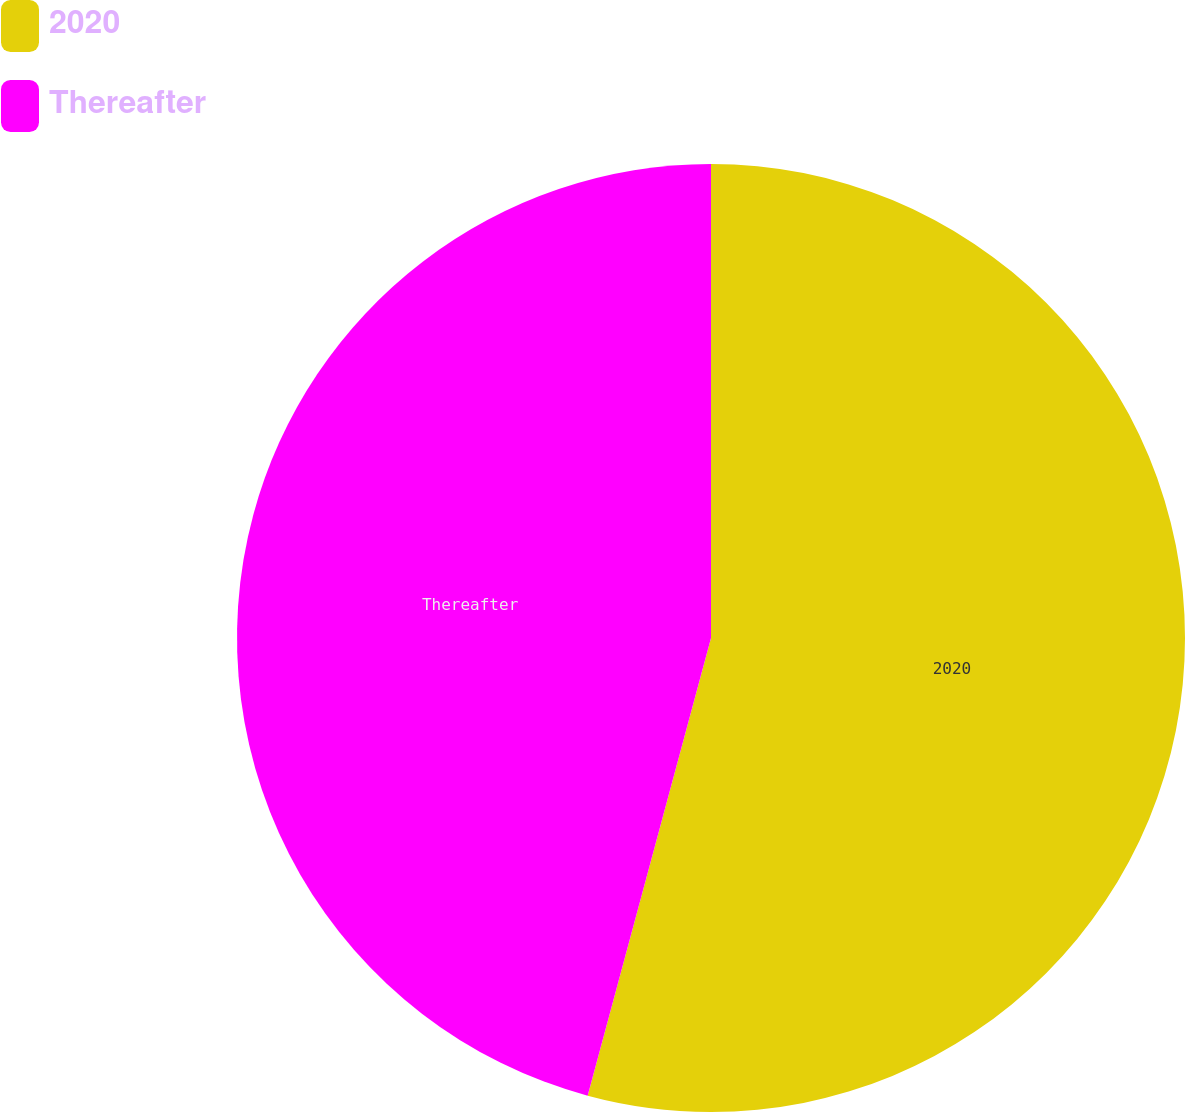Convert chart. <chart><loc_0><loc_0><loc_500><loc_500><pie_chart><fcel>2020<fcel>Thereafter<nl><fcel>54.19%<fcel>45.81%<nl></chart> 